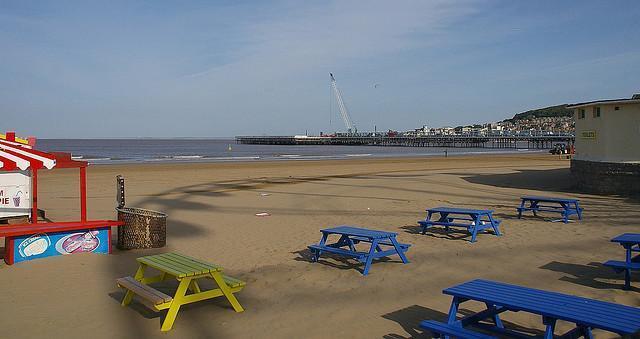How many benches are there?
Give a very brief answer. 2. 